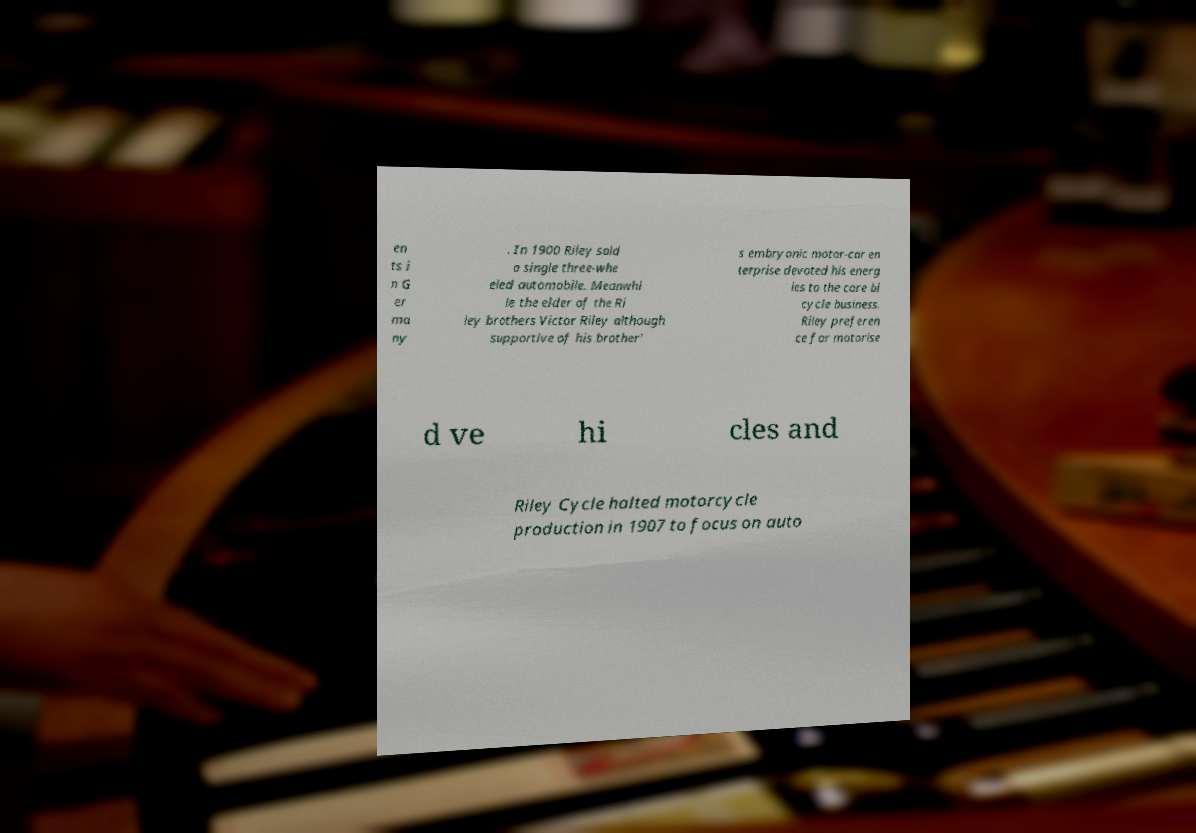Can you read and provide the text displayed in the image?This photo seems to have some interesting text. Can you extract and type it out for me? en ts i n G er ma ny . In 1900 Riley sold a single three-whe eled automobile. Meanwhi le the elder of the Ri ley brothers Victor Riley although supportive of his brother' s embryonic motor-car en terprise devoted his energ ies to the core bi cycle business. Riley preferen ce for motorise d ve hi cles and Riley Cycle halted motorcycle production in 1907 to focus on auto 